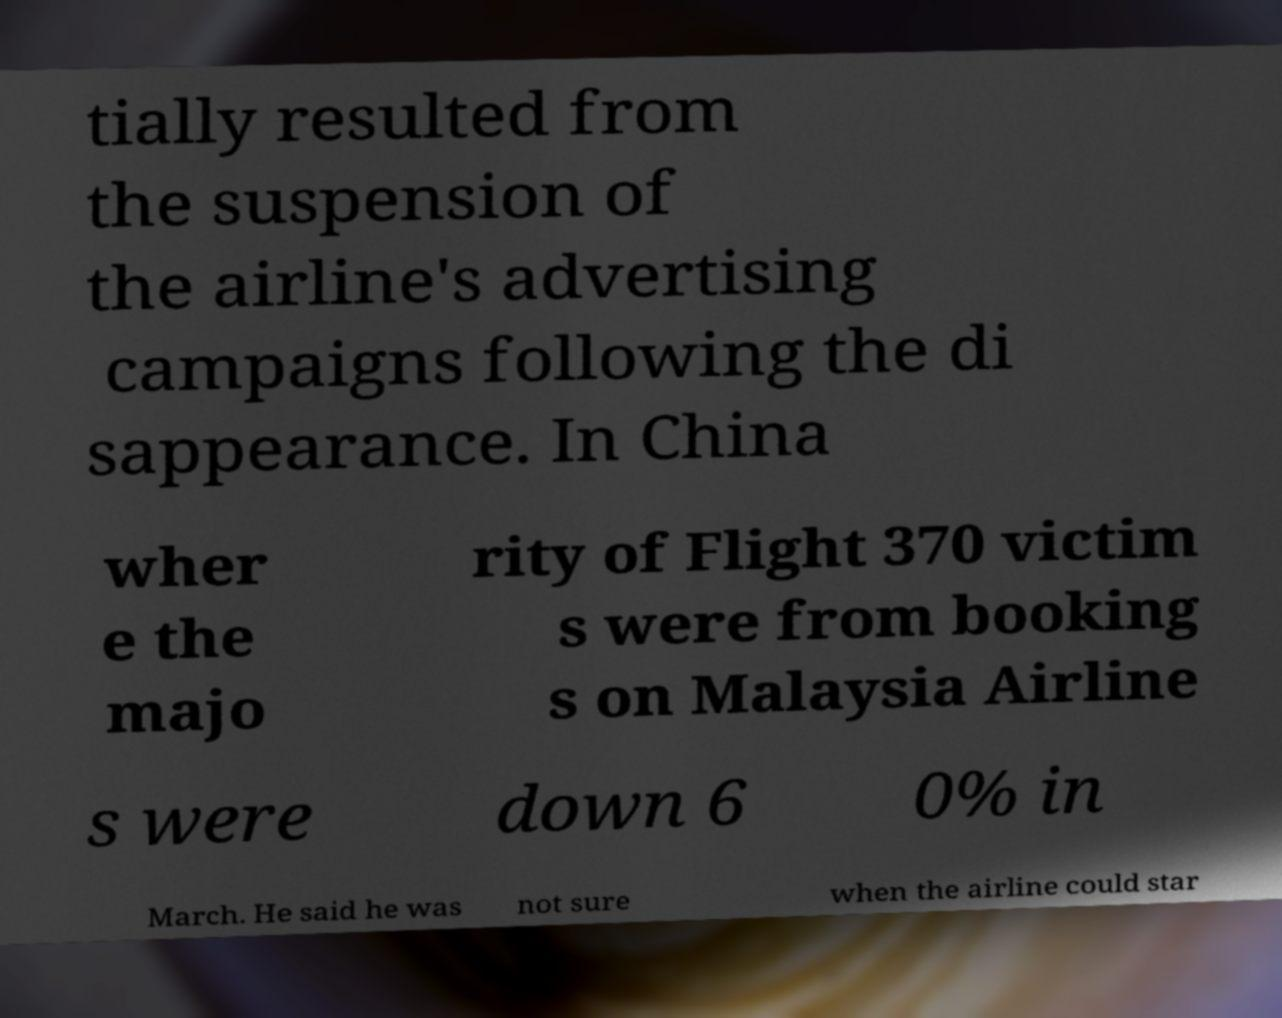Please read and relay the text visible in this image. What does it say? tially resulted from the suspension of the airline's advertising campaigns following the di sappearance. In China wher e the majo rity of Flight 370 victim s were from booking s on Malaysia Airline s were down 6 0% in March. He said he was not sure when the airline could star 